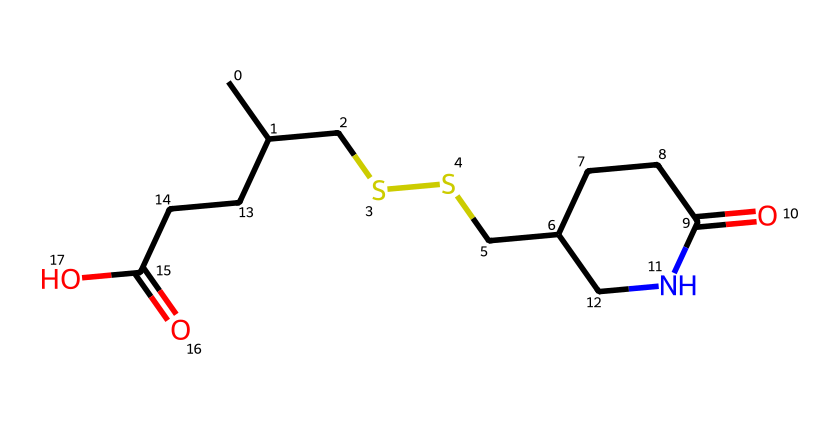What is the molecular formula of alpha-lipoic acid? The SMILES representation implies the presence of carbon (C), hydrogen (H), oxygen (O), and nitrogen (N) atoms. By counting, there are 12 carbon atoms, 19 hydrogen atoms, 2 oxygen atoms, and 1 nitrogen atom, leading to the molecular formula C12H19N2O2.
Answer: C12H19N2O2 How many stereocenters are present in the chemical structure? By analyzing the structure from the SMILES representation, we can identify that there are two carbon atoms bonded to four different groups, which indicates two stereocenters.
Answer: 2 What type of functional groups can be identified in alpha-lipoic acid? Analyzing the structure from the SMILES string reveals carboxylic acid (—COOH) and amide (—C(=O)N—) functional groups present in the molecule.
Answer: carboxylic acid, amide What is the role of alpha-lipoic acid as an antioxidant? Alpha-lipoic acid acts by scavenging free radicals and regenerating other antioxidants, which protects cells from oxidative stress. This mechanism contributes to its classification as an antioxidant.
Answer: scavenging free radicals How does the presence of sulfur in alpha-lipoic acid contribute to its antioxidant properties? The sulfur atom in the structure allows alpha-lipoic acid to donate electrons easily, facilitating the reduction of oxidized molecules and enhancing its ability as an antioxidant.
Answer: enhances electron donation What is the significance of the amide group in alpha-lipoic acid? The amide group stabilizes the molecule and is involved in maintaining protein structure, which is essential for biological activity and interactions in the body.
Answer: stabilizes and maintains protein structure 